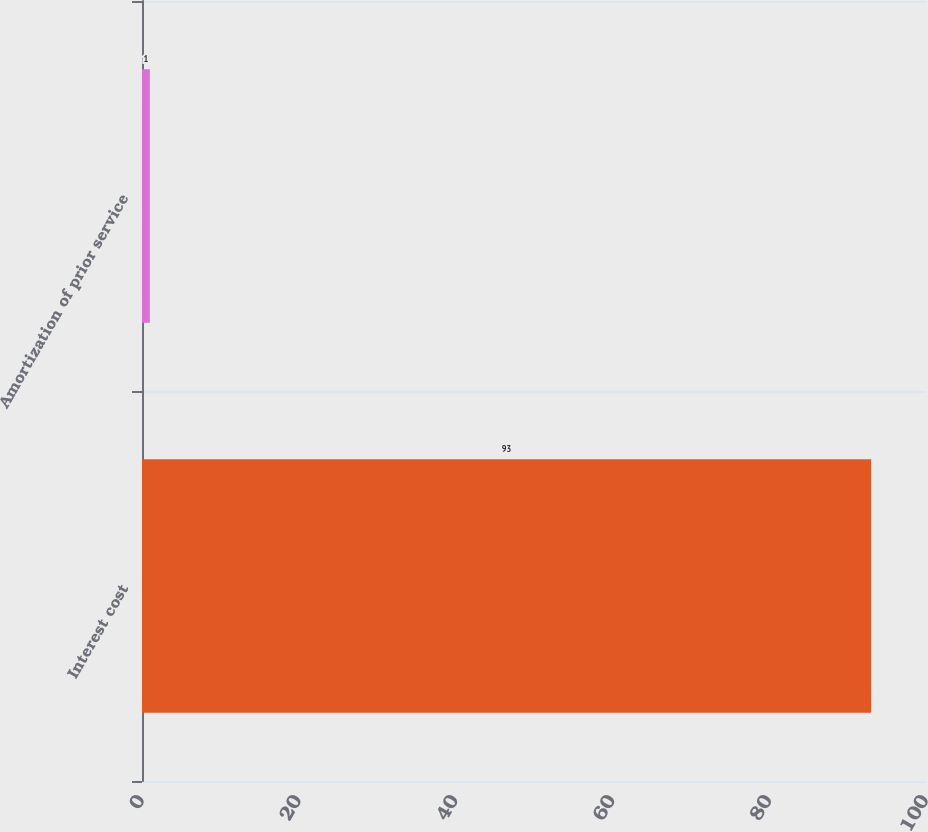<chart> <loc_0><loc_0><loc_500><loc_500><bar_chart><fcel>Interest cost<fcel>Amortization of prior service<nl><fcel>93<fcel>1<nl></chart> 